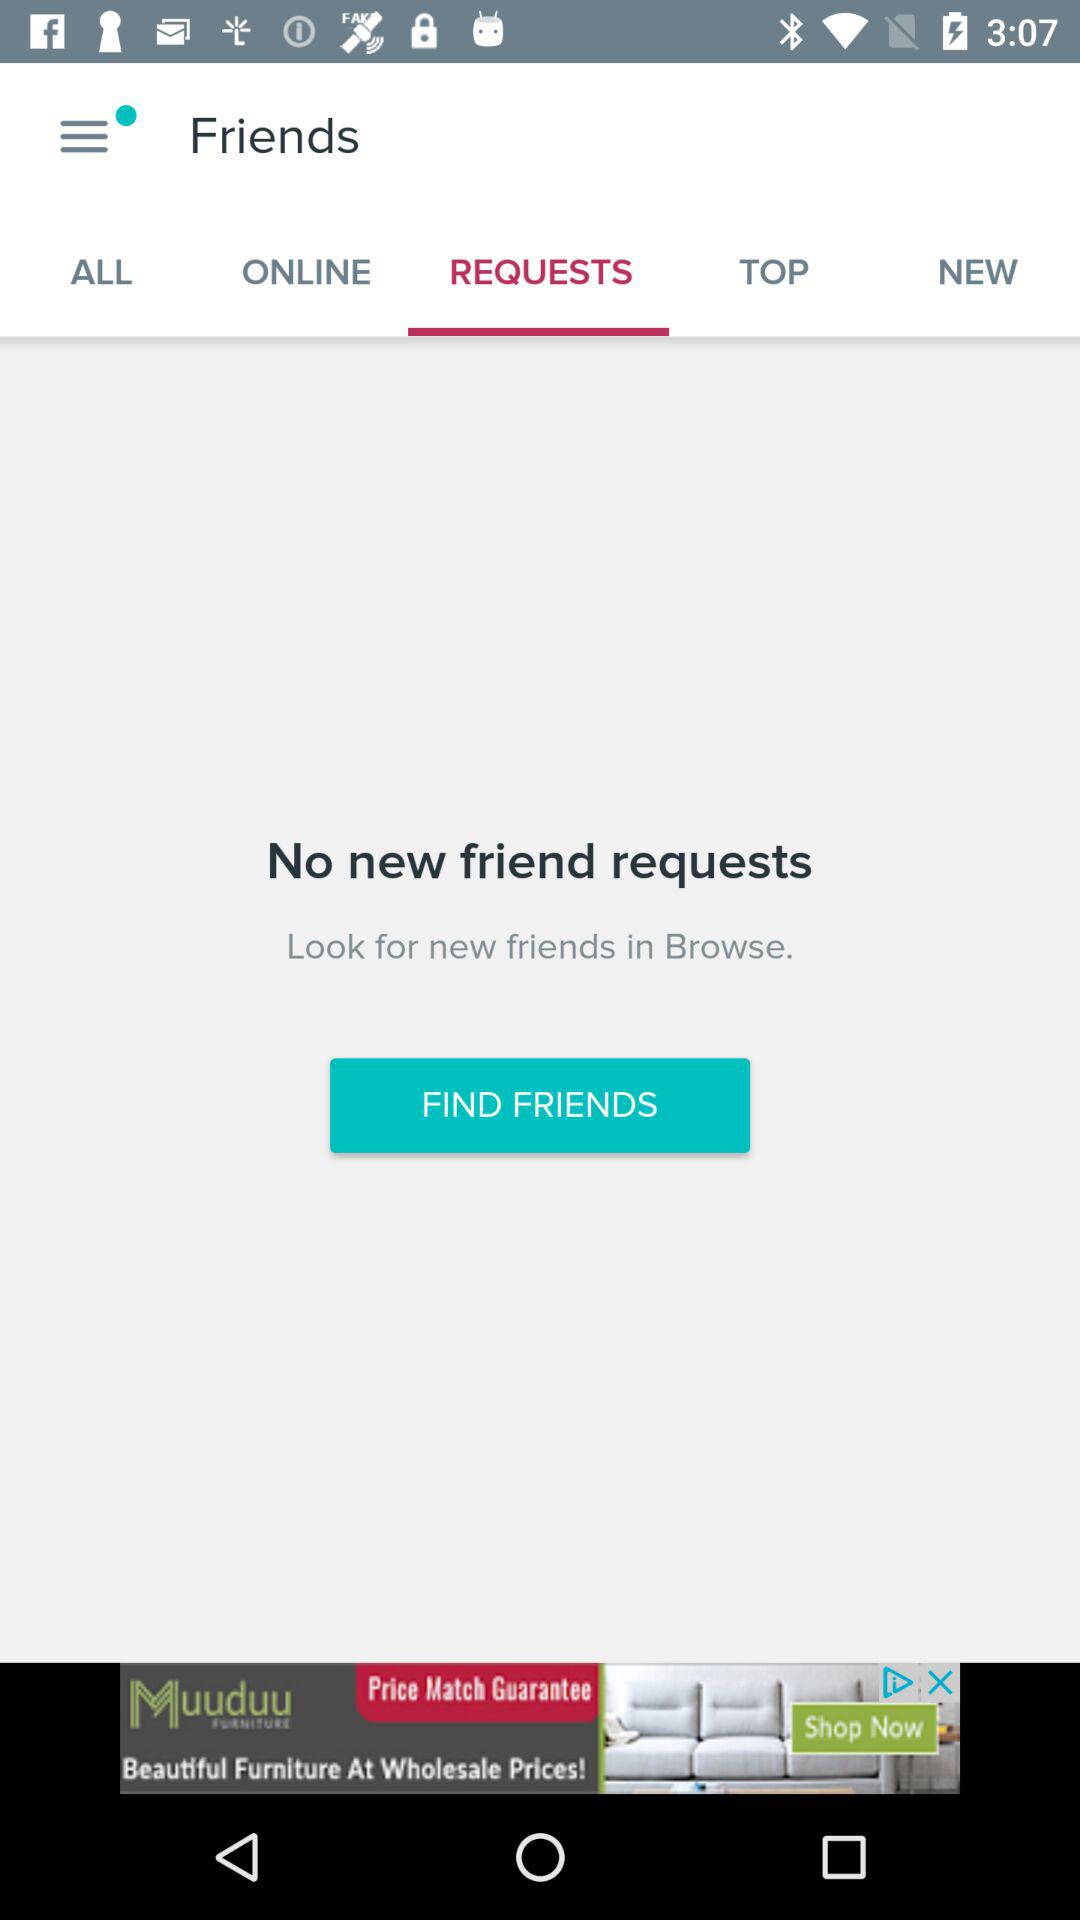How many friend requests do I have?
Answer the question using a single word or phrase. 0 